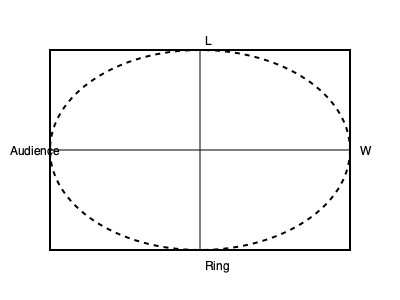As the rightful champion, you're designing a new wrestling ring to showcase your dominance. Given a rectangular arena with width W and length L, what should be the optimal shape of the wrestling ring to maximize the viewing angles for the audience? Assume the audience is seated along the perimeter of the arena, and the ring should have the largest possible area while maintaining a minimum distance of 10 feet from the arena walls. Express your answer in terms of W and L. To maximize viewing angles and ring area while maintaining a minimum distance from the walls, we should use an elliptical shape for the ring. Here's why:

1. An ellipse provides better viewing angles compared to a rectangle or square, as its curved shape allows for more uniform visibility from all sides.

2. The ellipse should be centered in the arena to ensure equal distance from all walls.

3. To maintain the 10-foot minimum distance, the semi-major and semi-minor axes of the ellipse should be:
   
   Semi-major axis: $a = \frac{W}{2} - 10$
   Semi-minor axis: $b = \frac{L}{2} - 10$

4. The area of an ellipse is given by the formula: $A = \pi ab$

5. Substituting our expressions for $a$ and $b$:

   $A = \pi (\frac{W}{2} - 10)(\frac{L}{2} - 10)$

6. Expanding the expression:

   $A = \pi (\frac{WL}{4} - 5L - 5W + 100)$

7. This expression represents the maximum possible area for the elliptical ring while maintaining the required distance from the walls.

The optimal shape is therefore an ellipse with semi-major axis $a = \frac{W}{2} - 10$ and semi-minor axis $b = \frac{L}{2} - 10$, centered in the rectangular arena.
Answer: Ellipse with semi-major axis $\frac{W}{2} - 10$ and semi-minor axis $\frac{L}{2} - 10$ 